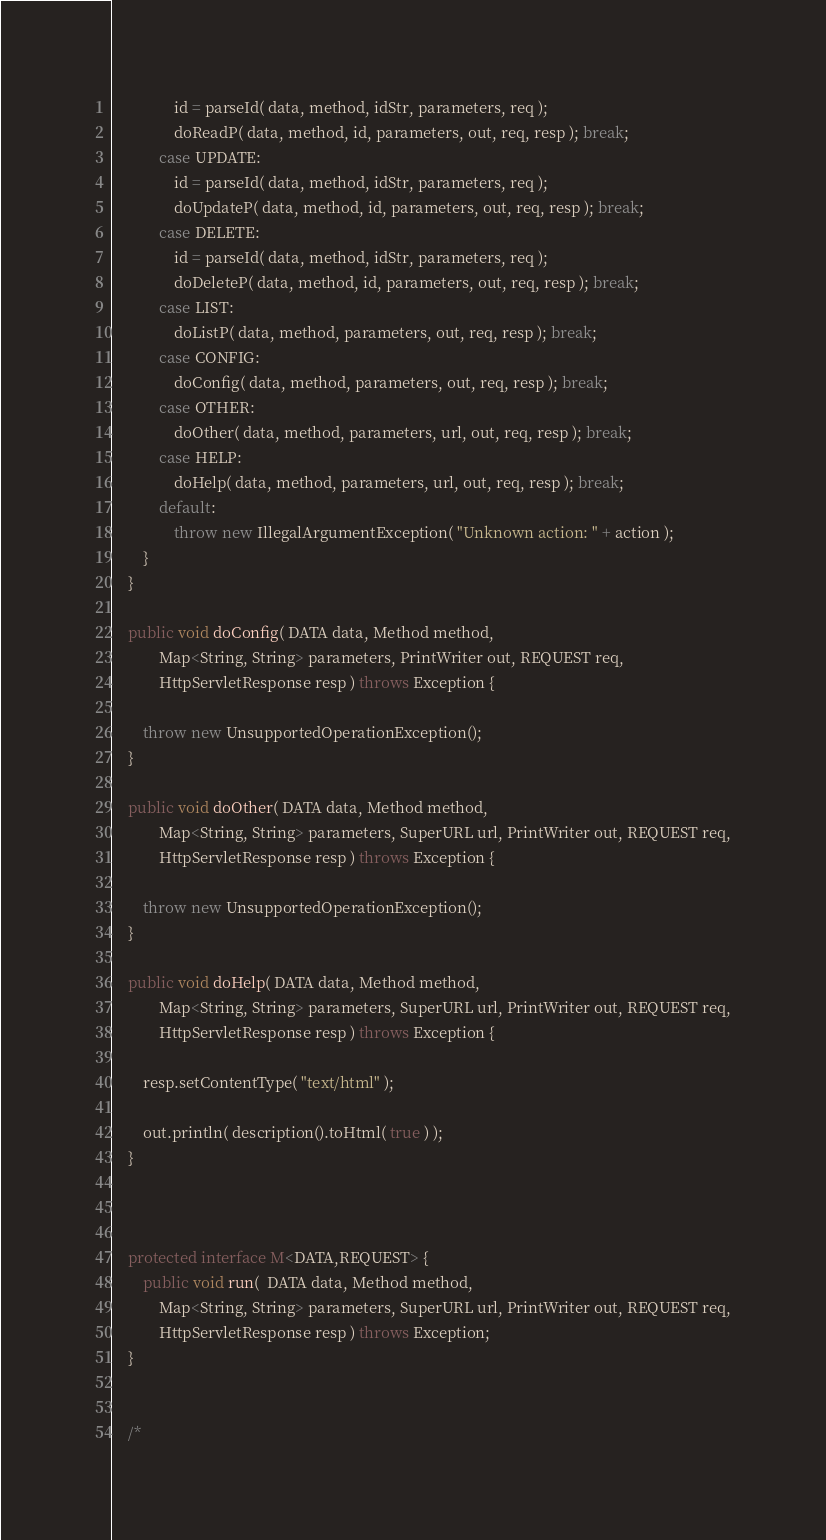<code> <loc_0><loc_0><loc_500><loc_500><_Java_>				id = parseId( data, method, idStr, parameters, req );
				doReadP( data, method, id, parameters, out, req, resp ); break;
			case UPDATE:
				id = parseId( data, method, idStr, parameters, req );
				doUpdateP( data, method, id, parameters, out, req, resp ); break;
			case DELETE:
				id = parseId( data, method, idStr, parameters, req );
				doDeleteP( data, method, id, parameters, out, req, resp ); break;
			case LIST:
				doListP( data, method, parameters, out, req, resp ); break;
			case CONFIG:
				doConfig( data, method, parameters, out, req, resp ); break;
			case OTHER:
				doOther( data, method, parameters, url, out, req, resp ); break;
			case HELP:
				doHelp( data, method, parameters, url, out, req, resp ); break;
			default:
				throw new IllegalArgumentException( "Unknown action: " + action );
		}
	}

	public void doConfig( DATA data, Method method,
			Map<String, String> parameters, PrintWriter out, REQUEST req,
			HttpServletResponse resp ) throws Exception {

		throw new UnsupportedOperationException();
	}

	public void doOther( DATA data, Method method,
			Map<String, String> parameters, SuperURL url, PrintWriter out, REQUEST req,
			HttpServletResponse resp ) throws Exception {

		throw new UnsupportedOperationException();
	}

	public void doHelp( DATA data, Method method,
			Map<String, String> parameters, SuperURL url, PrintWriter out, REQUEST req,
			HttpServletResponse resp ) throws Exception {

		resp.setContentType( "text/html" );

		out.println( description().toHtml( true ) );
	}



	protected interface M<DATA,REQUEST> {
		public void run(  DATA data, Method method,
			Map<String, String> parameters, SuperURL url, PrintWriter out, REQUEST req,
			HttpServletResponse resp ) throws Exception;
	}


	/*</code> 